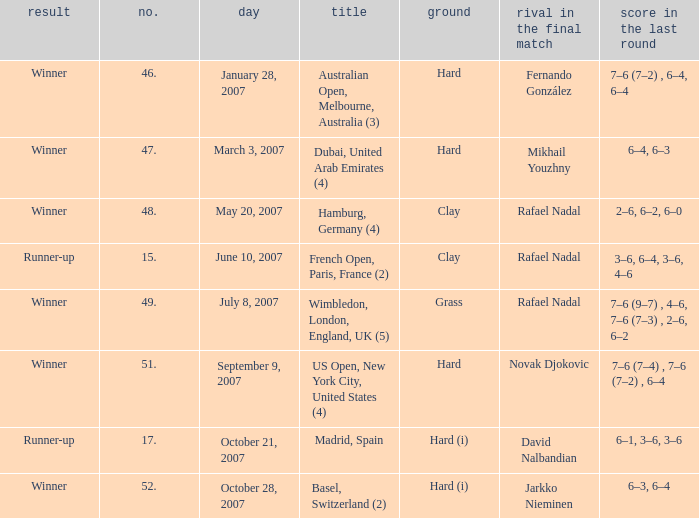Where the conclusion is winner and ground is hard (i), what is the no.? 52.0. 